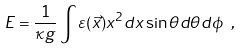Convert formula to latex. <formula><loc_0><loc_0><loc_500><loc_500>E = \frac { 1 } { \kappa g } \int \varepsilon ( \vec { x } ) x ^ { 2 } d x \sin \theta d \theta d \phi \ ,</formula> 